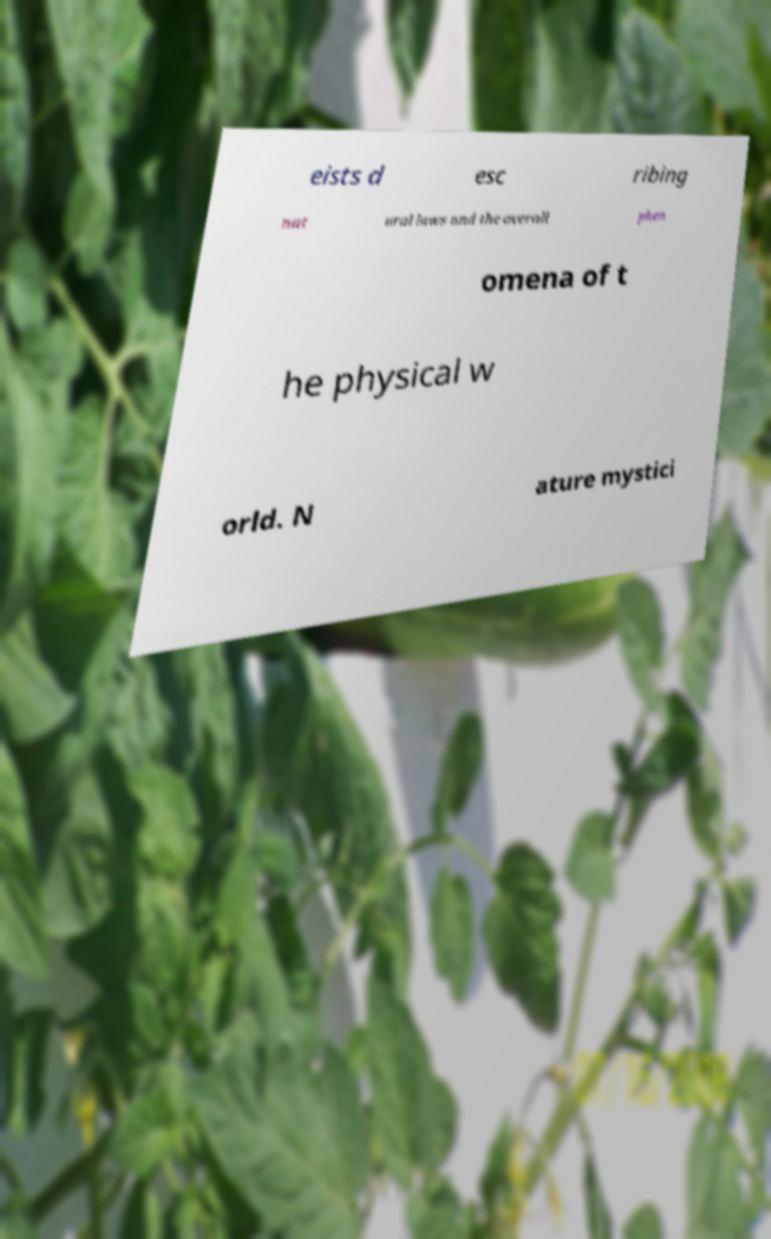For documentation purposes, I need the text within this image transcribed. Could you provide that? eists d esc ribing nat ural laws and the overall phen omena of t he physical w orld. N ature mystici 